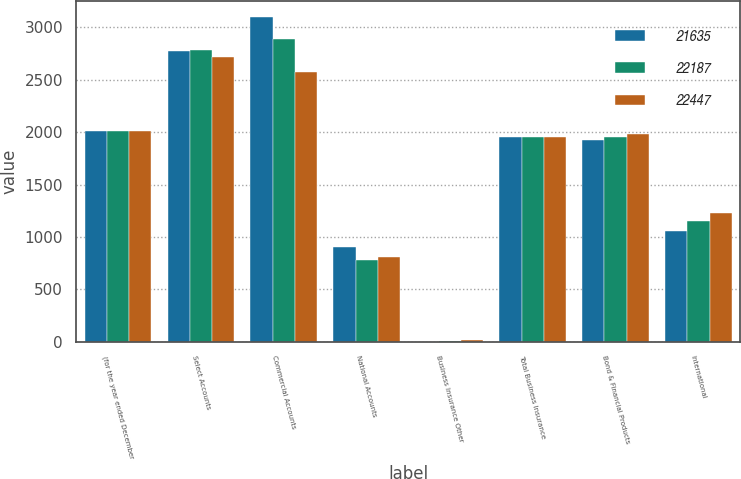Convert chart to OTSL. <chart><loc_0><loc_0><loc_500><loc_500><stacked_bar_chart><ecel><fcel>(for the year ended December<fcel>Select Accounts<fcel>Commercial Accounts<fcel>National Accounts<fcel>Business Insurance Other<fcel>Total Business Insurance<fcel>Bond & Financial Products<fcel>International<nl><fcel>21635<fcel>2012<fcel>2775<fcel>3101<fcel>907<fcel>1<fcel>1953<fcel>1924<fcel>1057<nl><fcel>22187<fcel>2011<fcel>2784<fcel>2890<fcel>782<fcel>10<fcel>1953<fcel>1953<fcel>1149<nl><fcel>22447<fcel>2010<fcel>2718<fcel>2576<fcel>806<fcel>13<fcel>1953<fcel>1981<fcel>1230<nl></chart> 